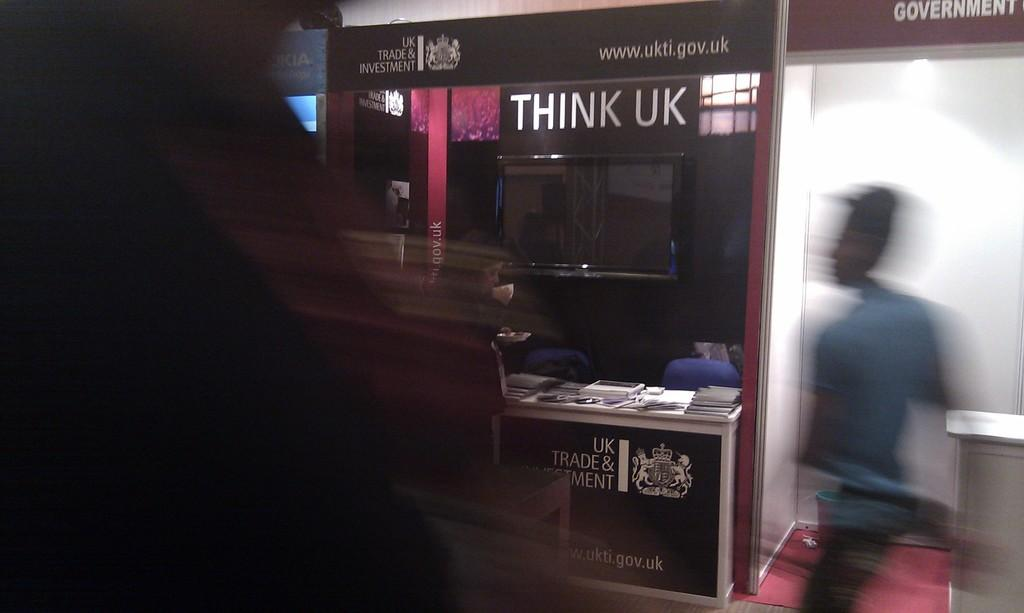<image>
Summarize the visual content of the image. a person walking next to a Think UK sign 